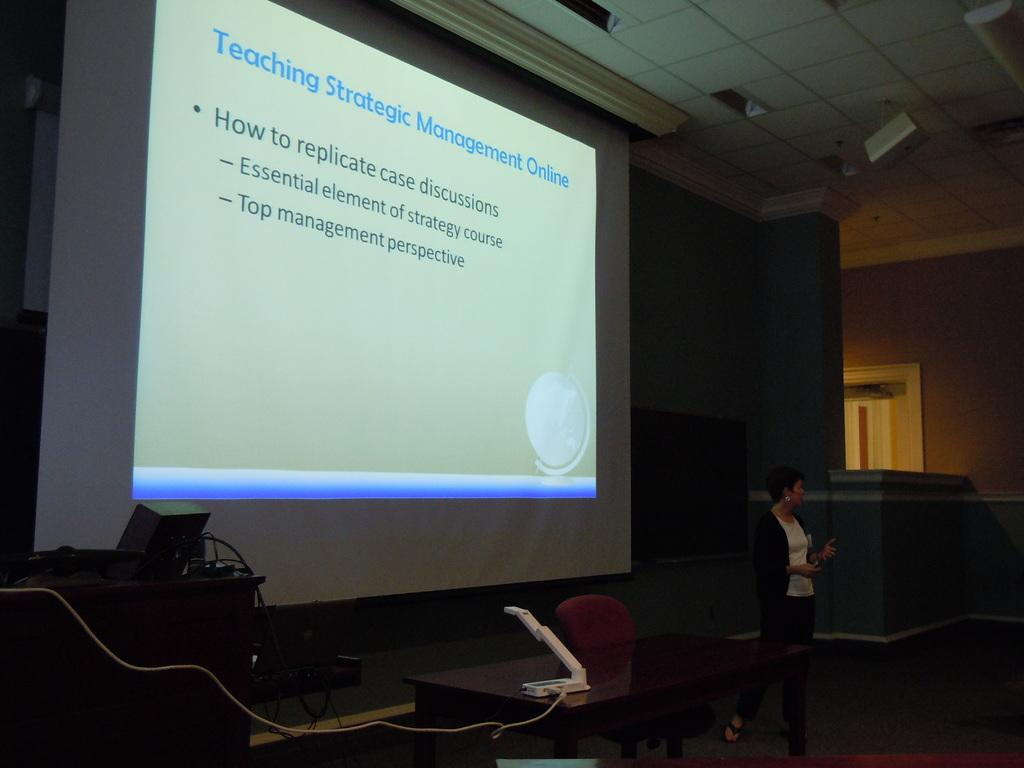What is the main object in the center of the image? There is a table in the center of the image. What piece of furniture is also present in the image? There is a chair in the image. What is the lady doing in the image? The lady is standing behind the table and presenting a presentation. What can be seen in the background of the image? There is a screen in the background of the image. How many bears are visible on the table in the image? There are no bears present on the table or in the image. What type of tooth is being used to present the presentation in the image? There is no tooth being used to present the presentation in the image; the lady is likely using a device such as a laptop or tablet. 